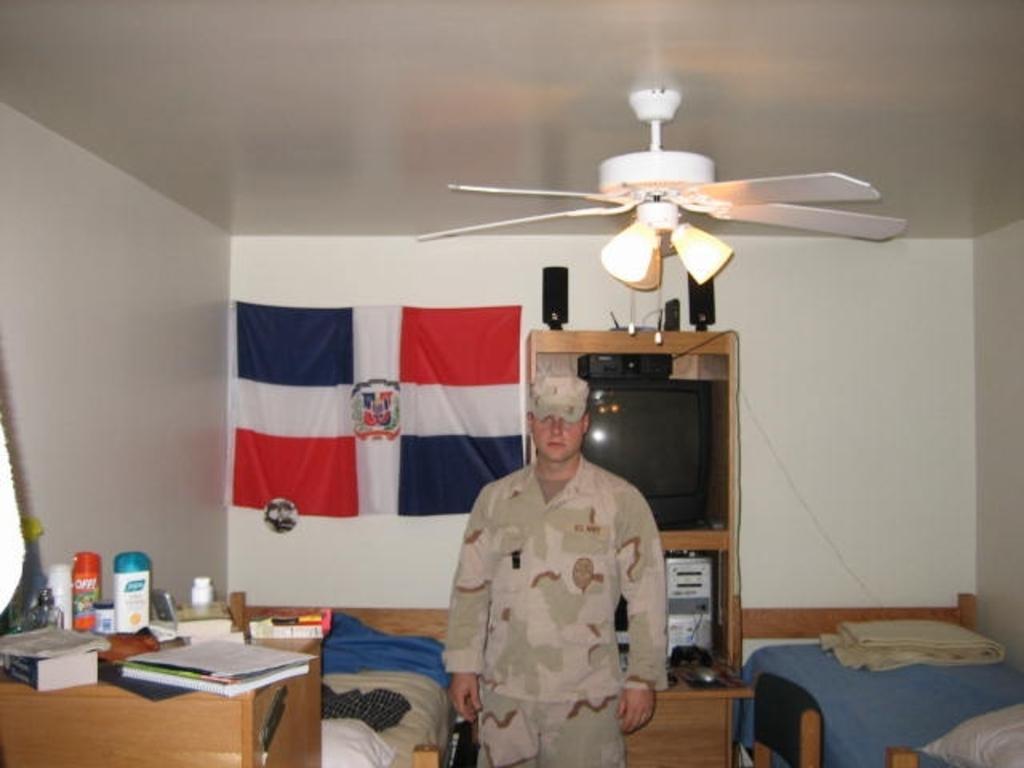Describe this image in one or two sentences. In the picture we can see a man with a uniform and cap, just beside him there is a table and chairs, On the table we can find books, bottles, tins and in the background we can find flag, television. On the ceiling a fan and lights. 